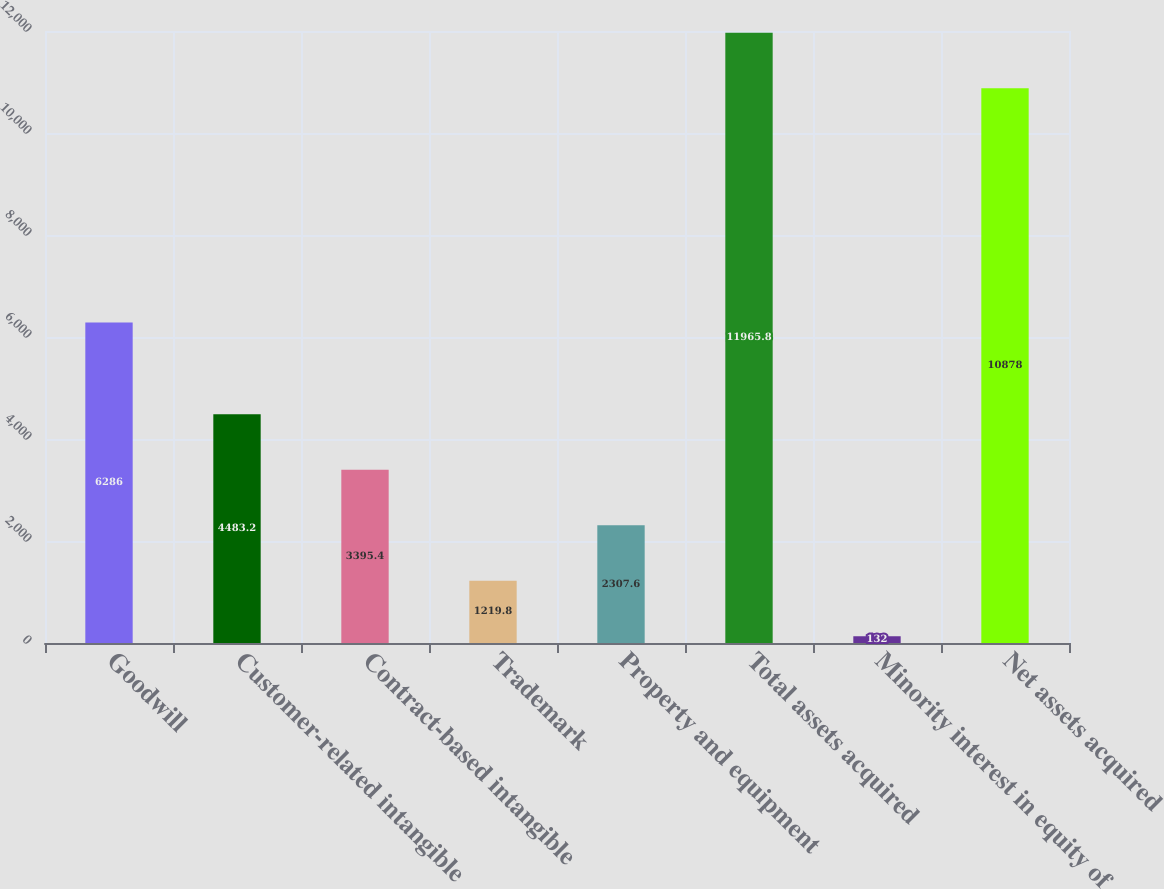Convert chart to OTSL. <chart><loc_0><loc_0><loc_500><loc_500><bar_chart><fcel>Goodwill<fcel>Customer-related intangible<fcel>Contract-based intangible<fcel>Trademark<fcel>Property and equipment<fcel>Total assets acquired<fcel>Minority interest in equity of<fcel>Net assets acquired<nl><fcel>6286<fcel>4483.2<fcel>3395.4<fcel>1219.8<fcel>2307.6<fcel>11965.8<fcel>132<fcel>10878<nl></chart> 